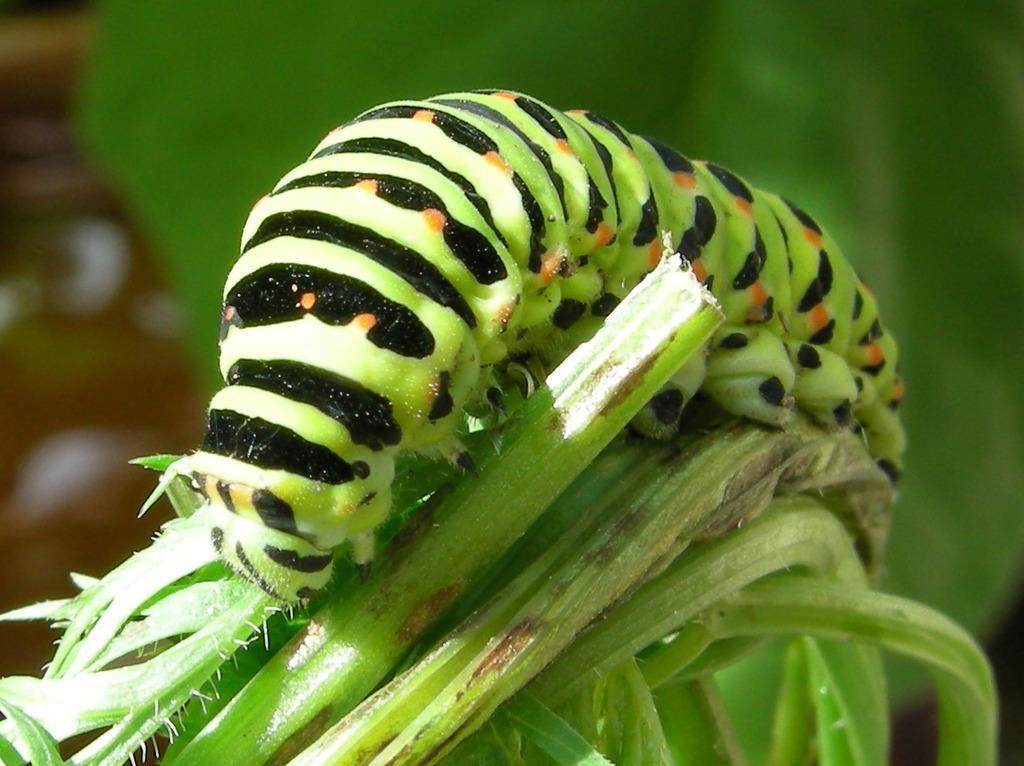Could you give a brief overview of what you see in this image? In the image there is a caterpillar crawling on the grass. 